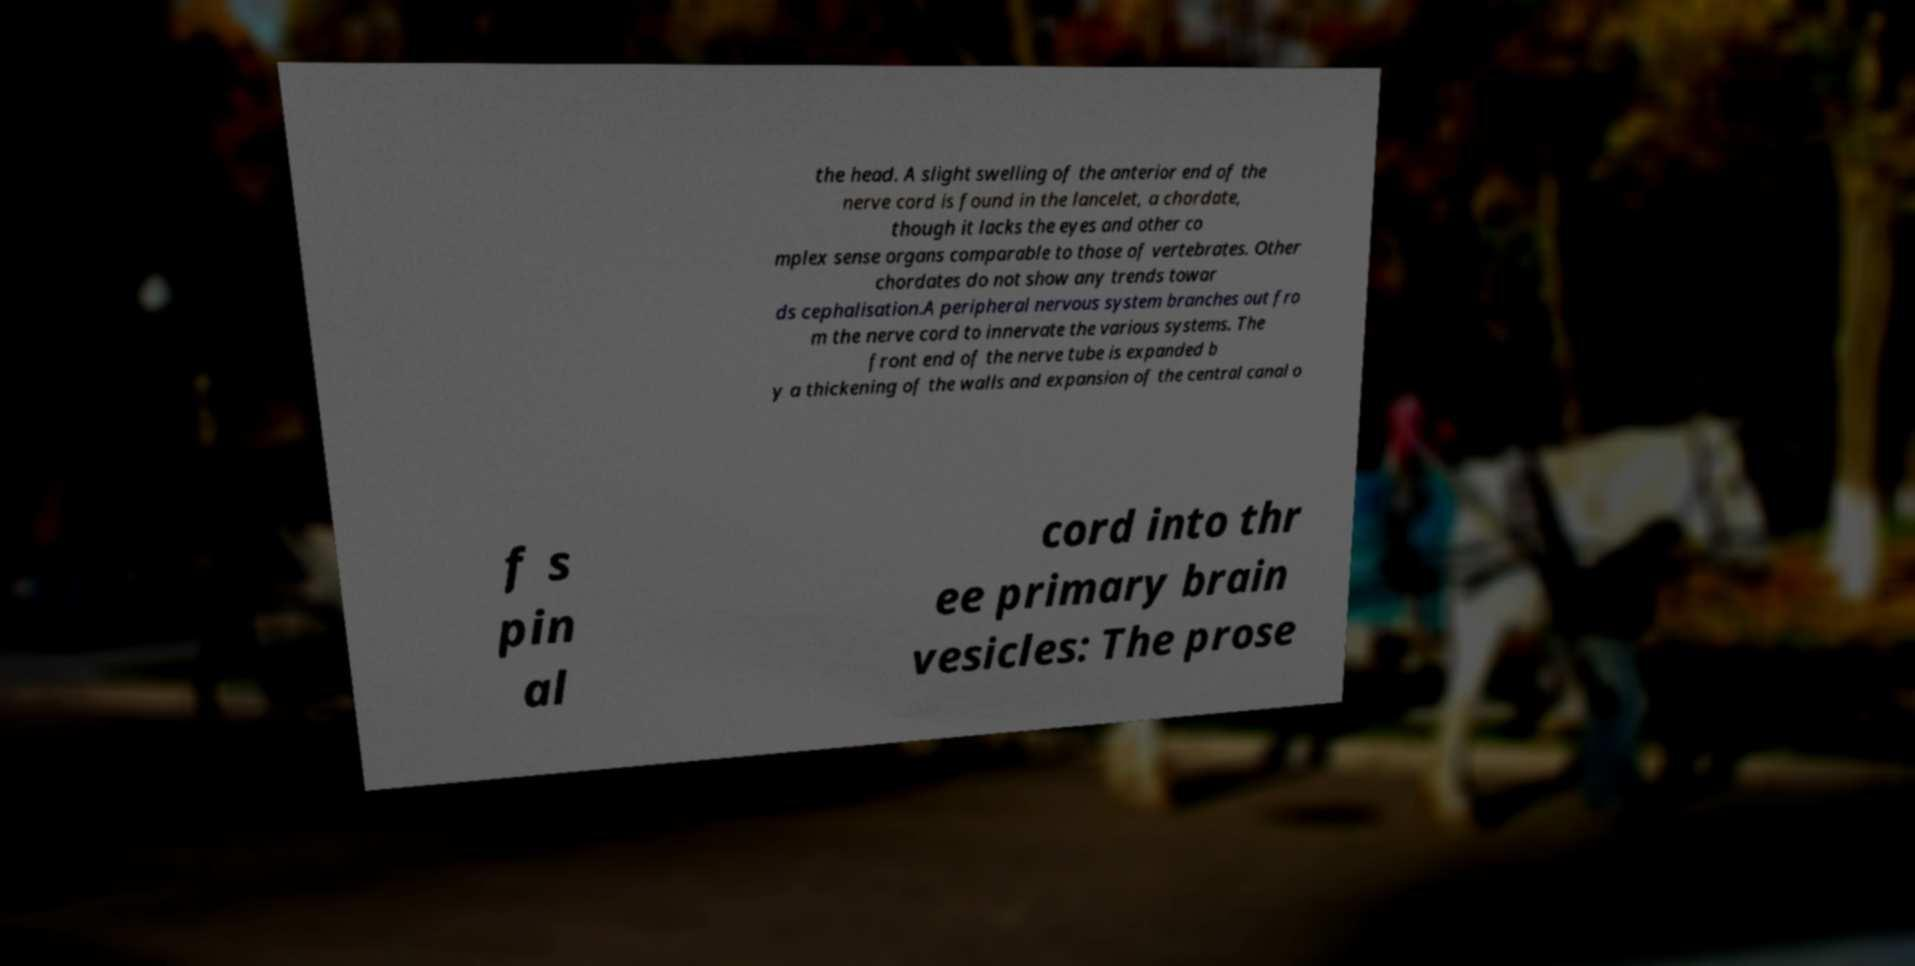Could you extract and type out the text from this image? the head. A slight swelling of the anterior end of the nerve cord is found in the lancelet, a chordate, though it lacks the eyes and other co mplex sense organs comparable to those of vertebrates. Other chordates do not show any trends towar ds cephalisation.A peripheral nervous system branches out fro m the nerve cord to innervate the various systems. The front end of the nerve tube is expanded b y a thickening of the walls and expansion of the central canal o f s pin al cord into thr ee primary brain vesicles: The prose 